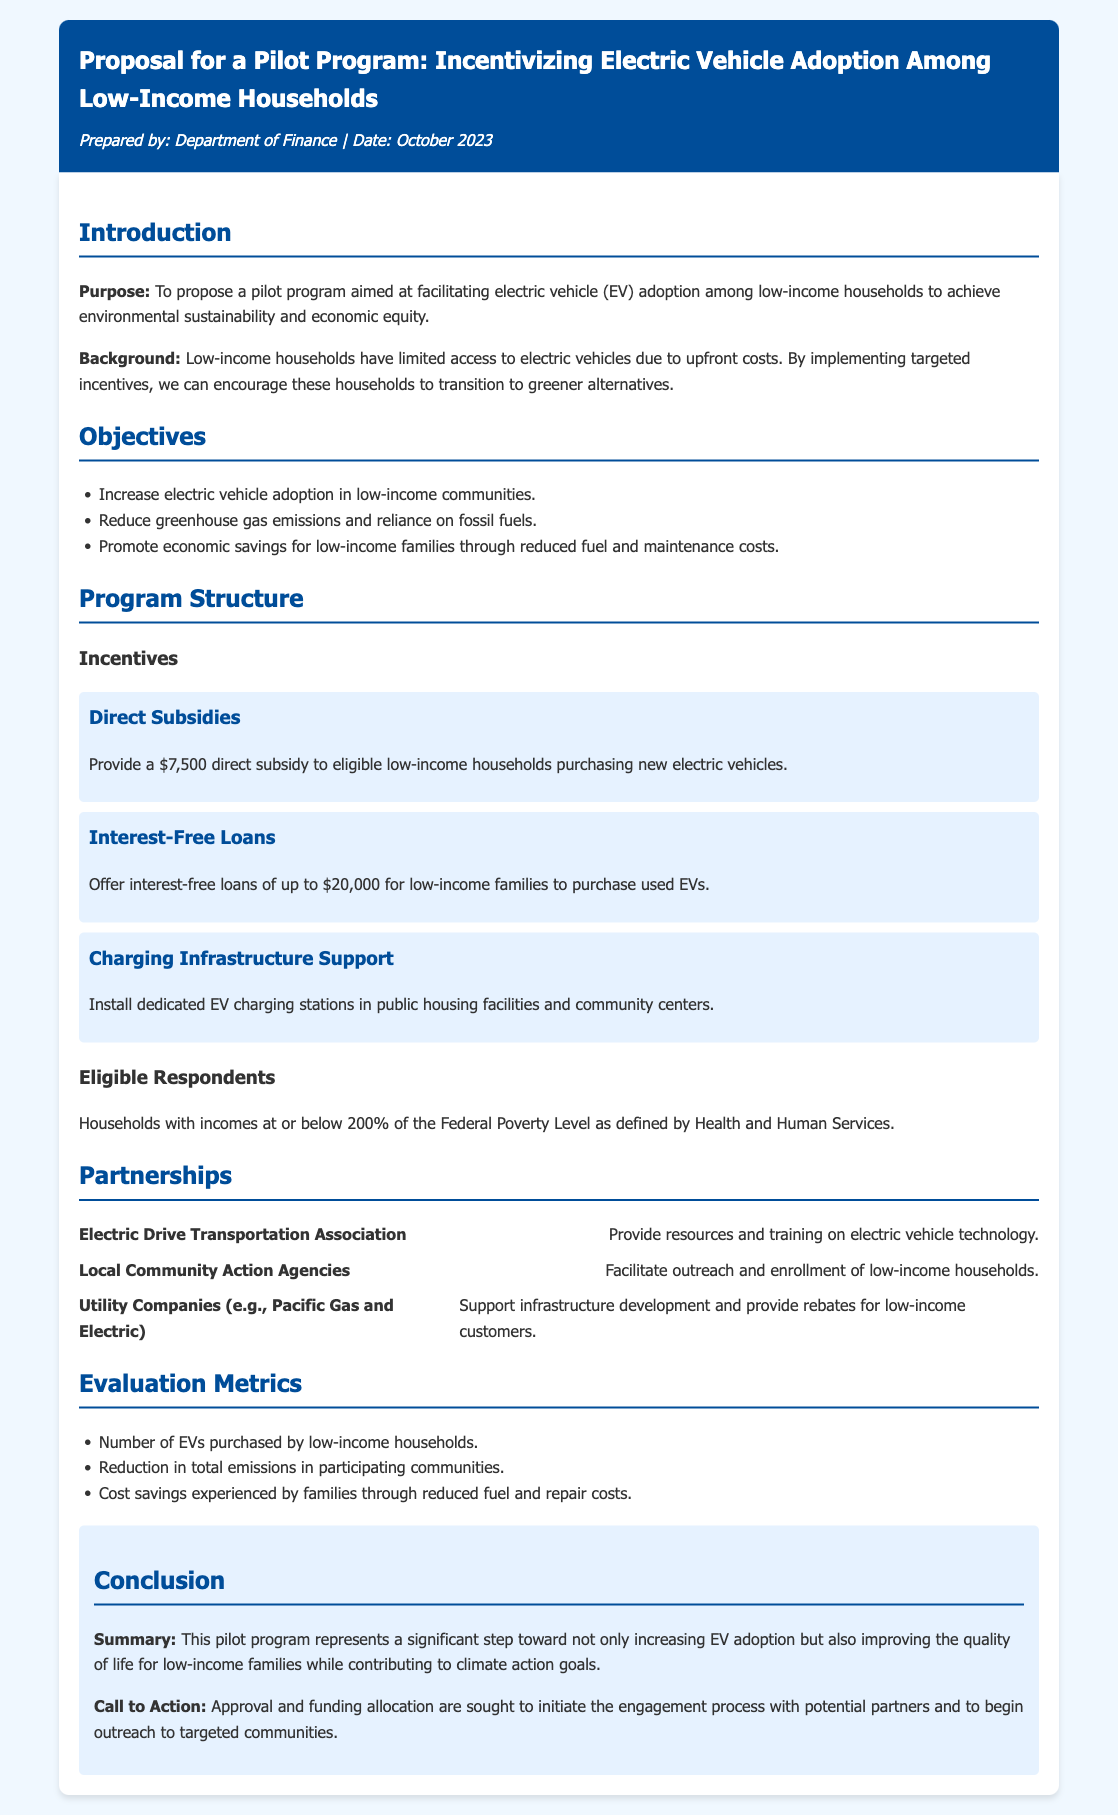What is the proposed subsidy amount for purchasing new electric vehicles? The document states that a $7,500 direct subsidy will be provided to eligible households purchasing new electric vehicles.
Answer: $7,500 What is the maximum amount for interest-free loans? The pilot program offers interest-free loans of up to $20,000 for low-income families to purchase used EVs.
Answer: $20,000 Who is the primary audience for this pilot program? The pilot program is aimed at low-income households that have limited access to electric vehicles due to upfront costs.
Answer: Low-income households What is one of the evaluation metrics mentioned in the document? The document lists the number of EVs purchased by low-income households as one of the evaluation metrics.
Answer: Number of EVs purchased Which organization will provide resources and training on electric vehicle technology? The Electric Drive Transportation Association will provide resources and training on electric vehicle technology.
Answer: Electric Drive Transportation Association What is the income threshold for household eligibility? Households with incomes at or below 200% of the Federal Poverty Level as defined by Health and Human Services are considered eligible.
Answer: 200% of the Federal Poverty Level What is the purpose of the pilot program? The purpose is to facilitate electric vehicle (EV) adoption among low-income households for environmental sustainability and economic equity.
Answer: Facilitate electric vehicle adoption What call to action is made in the conclusion? The conclusion seeks approval and funding allocation to initiate engagement with partners and outreach to targeted communities.
Answer: Approval and funding allocation 